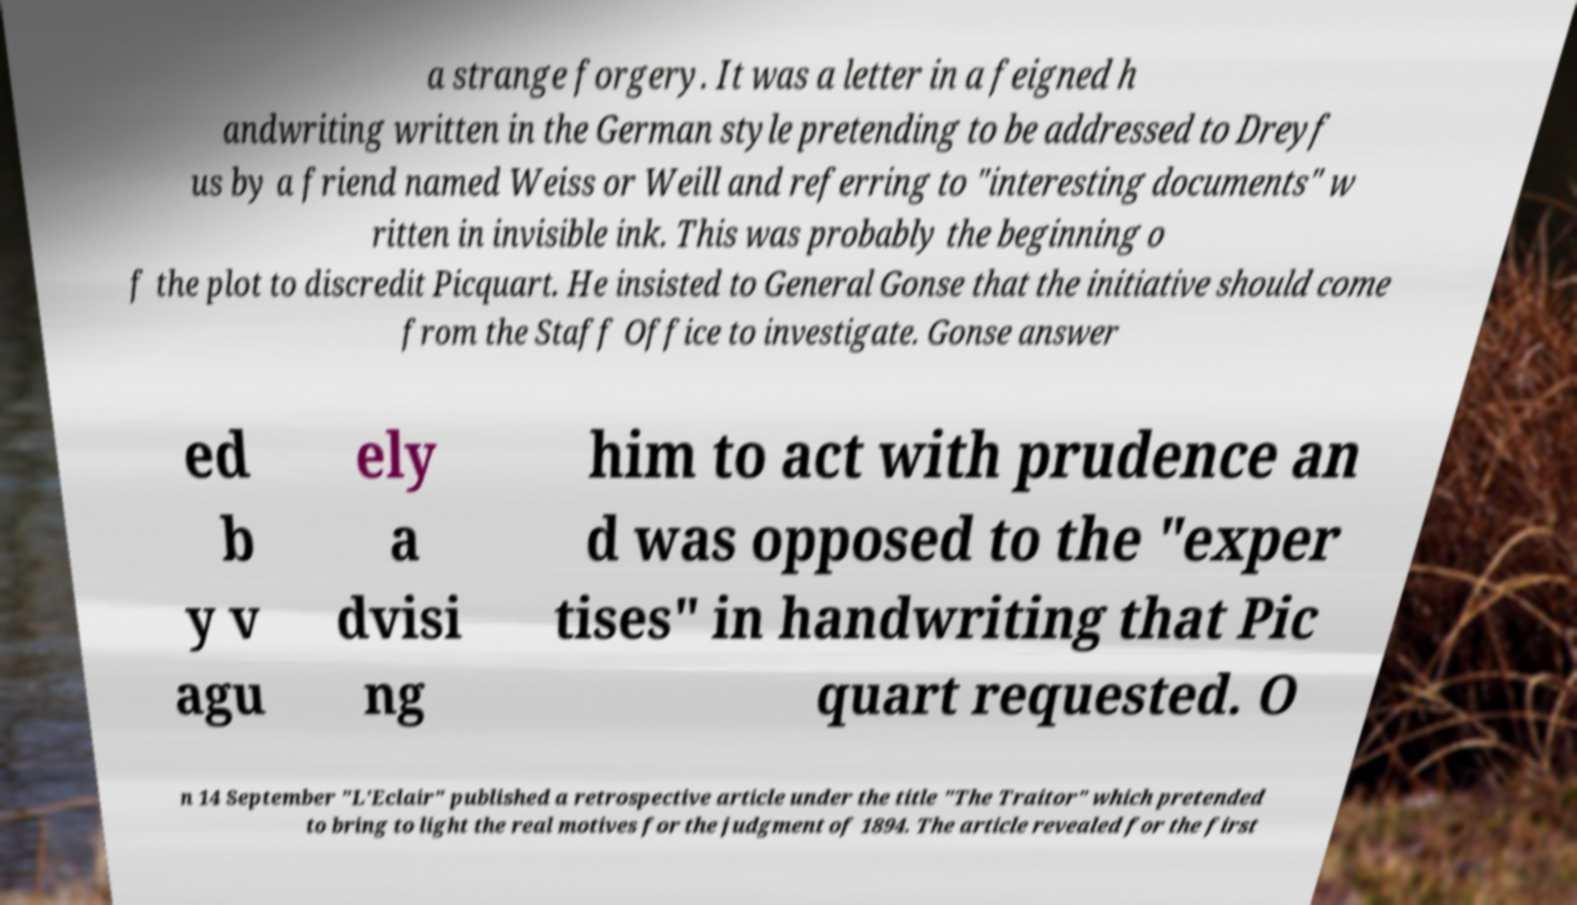Please identify and transcribe the text found in this image. a strange forgery. It was a letter in a feigned h andwriting written in the German style pretending to be addressed to Dreyf us by a friend named Weiss or Weill and referring to "interesting documents" w ritten in invisible ink. This was probably the beginning o f the plot to discredit Picquart. He insisted to General Gonse that the initiative should come from the Staff Office to investigate. Gonse answer ed b y v agu ely a dvisi ng him to act with prudence an d was opposed to the "exper tises" in handwriting that Pic quart requested. O n 14 September "L'Eclair" published a retrospective article under the title "The Traitor" which pretended to bring to light the real motives for the judgment of 1894. The article revealed for the first 